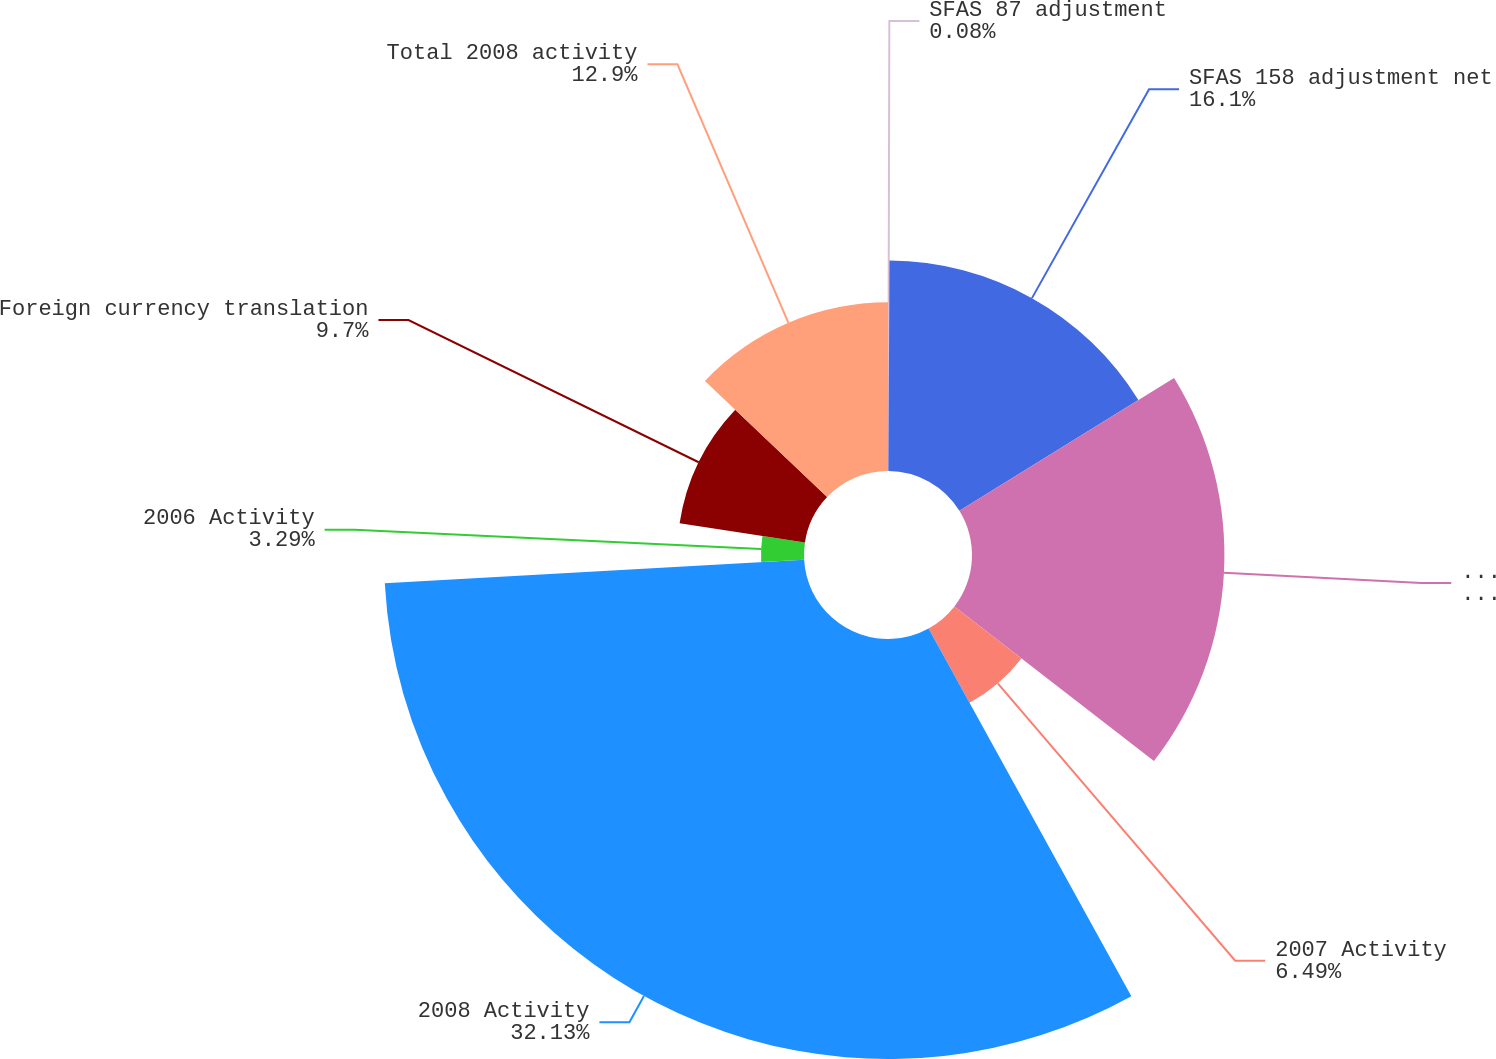Convert chart. <chart><loc_0><loc_0><loc_500><loc_500><pie_chart><fcel>SFAS 87 adjustment<fcel>SFAS 158 adjustment net<fcel>Total 2006 activity<fcel>2007 Activity<fcel>2008 Activity<fcel>2006 Activity<fcel>Foreign currency translation<fcel>Total 2008 activity<nl><fcel>0.08%<fcel>16.1%<fcel>19.31%<fcel>6.49%<fcel>32.13%<fcel>3.29%<fcel>9.7%<fcel>12.9%<nl></chart> 